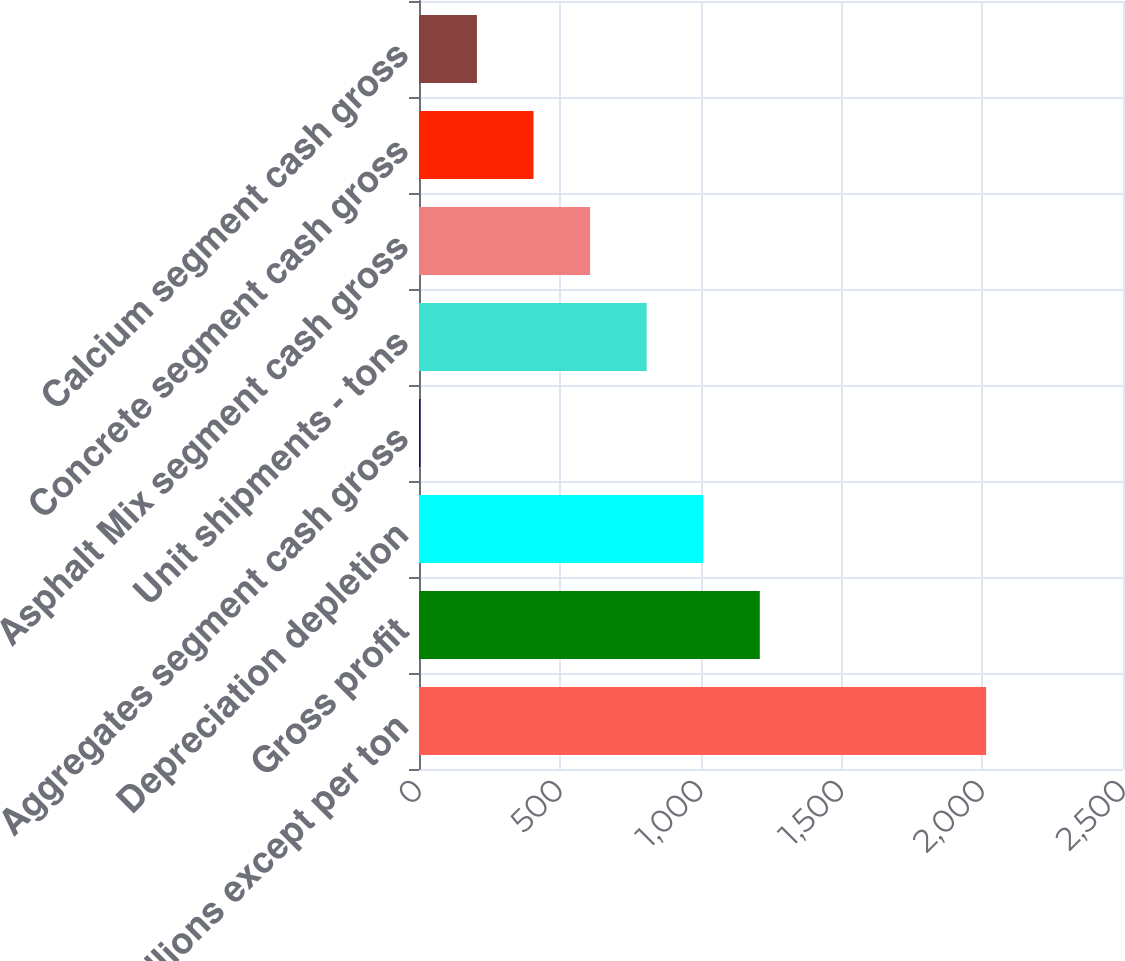Convert chart to OTSL. <chart><loc_0><loc_0><loc_500><loc_500><bar_chart><fcel>in millions except per ton<fcel>Gross profit<fcel>Depreciation depletion<fcel>Aggregates segment cash gross<fcel>Unit shipments - tons<fcel>Asphalt Mix segment cash gross<fcel>Concrete segment cash gross<fcel>Calcium segment cash gross<nl><fcel>2014<fcel>1210.31<fcel>1009.38<fcel>4.75<fcel>808.46<fcel>607.54<fcel>406.61<fcel>205.68<nl></chart> 